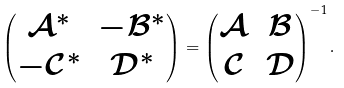Convert formula to latex. <formula><loc_0><loc_0><loc_500><loc_500>\begin{pmatrix} \mathcal { A } ^ { * } & - \mathcal { B } ^ { * } \\ - \mathcal { C } ^ { * } & \mathcal { D } ^ { * } \end{pmatrix} = \begin{pmatrix} \mathcal { A } & \mathcal { B } \\ \mathcal { C } & \mathcal { D } \end{pmatrix} ^ { - 1 } .</formula> 